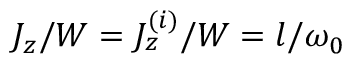Convert formula to latex. <formula><loc_0><loc_0><loc_500><loc_500>J _ { z } / W = J _ { z } ^ { ( i ) } / W = l / \omega _ { 0 }</formula> 